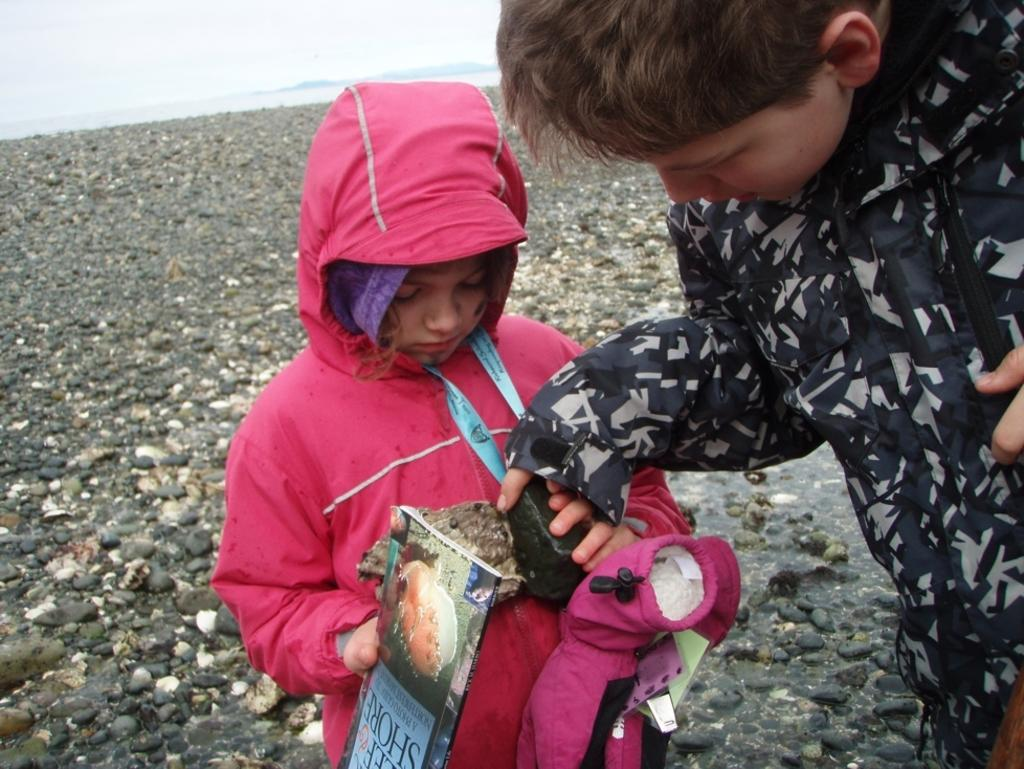What is the gender of the person on the right side of the image? There is a boy on the right side of the image. Are there any other people in the image besides the boy? Yes, there is a girl in the image. What is the girl wearing? The girl is wearing a pink jacket. What is the girl holding in the image? The girl is holding objects. What can be seen on the floor in the middle of the image? There are stones on the floor in the middle of the image. What type of horn can be heard in the image? There is no horn present in the image, and therefore no sound can be heard. 